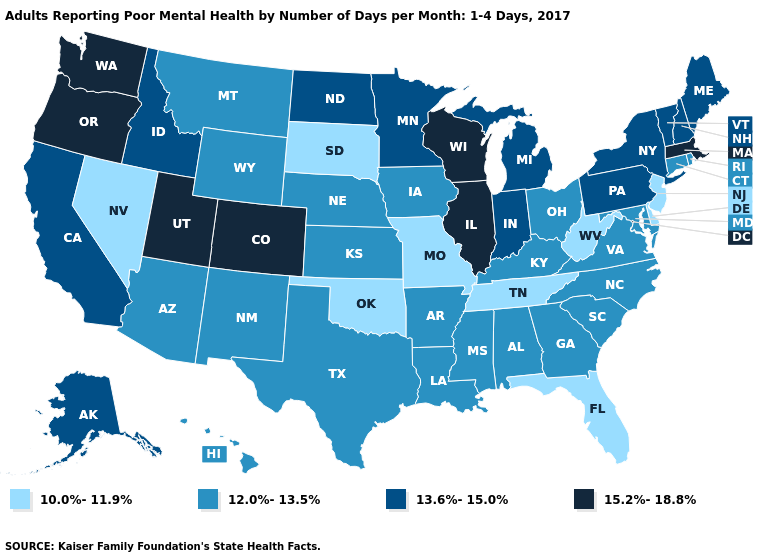What is the lowest value in the Northeast?
Answer briefly. 10.0%-11.9%. What is the value of Delaware?
Short answer required. 10.0%-11.9%. Among the states that border Virginia , does Maryland have the lowest value?
Quick response, please. No. Among the states that border Missouri , which have the lowest value?
Be succinct. Oklahoma, Tennessee. What is the highest value in the USA?
Concise answer only. 15.2%-18.8%. Does New York have the highest value in the USA?
Give a very brief answer. No. Among the states that border Texas , which have the lowest value?
Write a very short answer. Oklahoma. Among the states that border North Dakota , which have the highest value?
Answer briefly. Minnesota. Does Idaho have a higher value than Arizona?
Answer briefly. Yes. How many symbols are there in the legend?
Quick response, please. 4. Name the states that have a value in the range 15.2%-18.8%?
Answer briefly. Colorado, Illinois, Massachusetts, Oregon, Utah, Washington, Wisconsin. Among the states that border Delaware , which have the highest value?
Write a very short answer. Pennsylvania. What is the value of New Hampshire?
Quick response, please. 13.6%-15.0%. Among the states that border Wyoming , does Idaho have the lowest value?
Write a very short answer. No. 